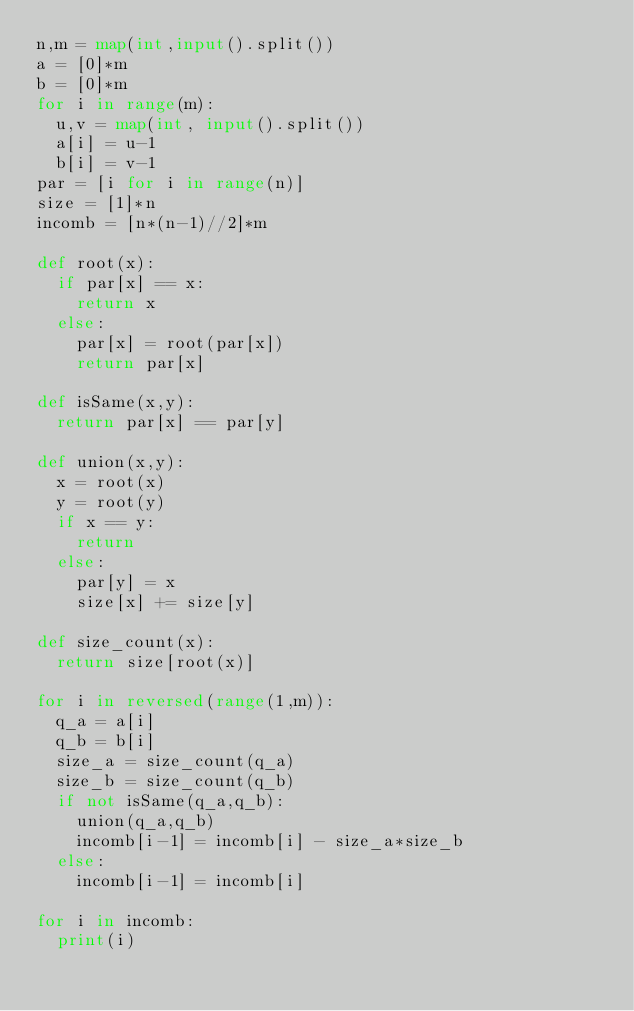<code> <loc_0><loc_0><loc_500><loc_500><_Python_>n,m = map(int,input().split())
a = [0]*m
b = [0]*m
for i in range(m):
  u,v = map(int, input().split())
  a[i] = u-1
  b[i] = v-1
par = [i for i in range(n)]
size = [1]*n
incomb = [n*(n-1)//2]*m

def root(x):
  if par[x] == x: 
    return x
  else:
    par[x] = root(par[x])
    return par[x]
    
def isSame(x,y):
  return par[x] == par[y]

def union(x,y):
  x = root(x)
  y = root(y)
  if x == y:
    return
  else:
    par[y] = x
    size[x] += size[y]
    
def size_count(x):
  return size[root(x)]

for i in reversed(range(1,m)):
  q_a = a[i]
  q_b = b[i]
  size_a = size_count(q_a)
  size_b = size_count(q_b)
  if not isSame(q_a,q_b):
    union(q_a,q_b)
    incomb[i-1] = incomb[i] - size_a*size_b
  else:
    incomb[i-1] = incomb[i]

for i in incomb:
  print(i)</code> 